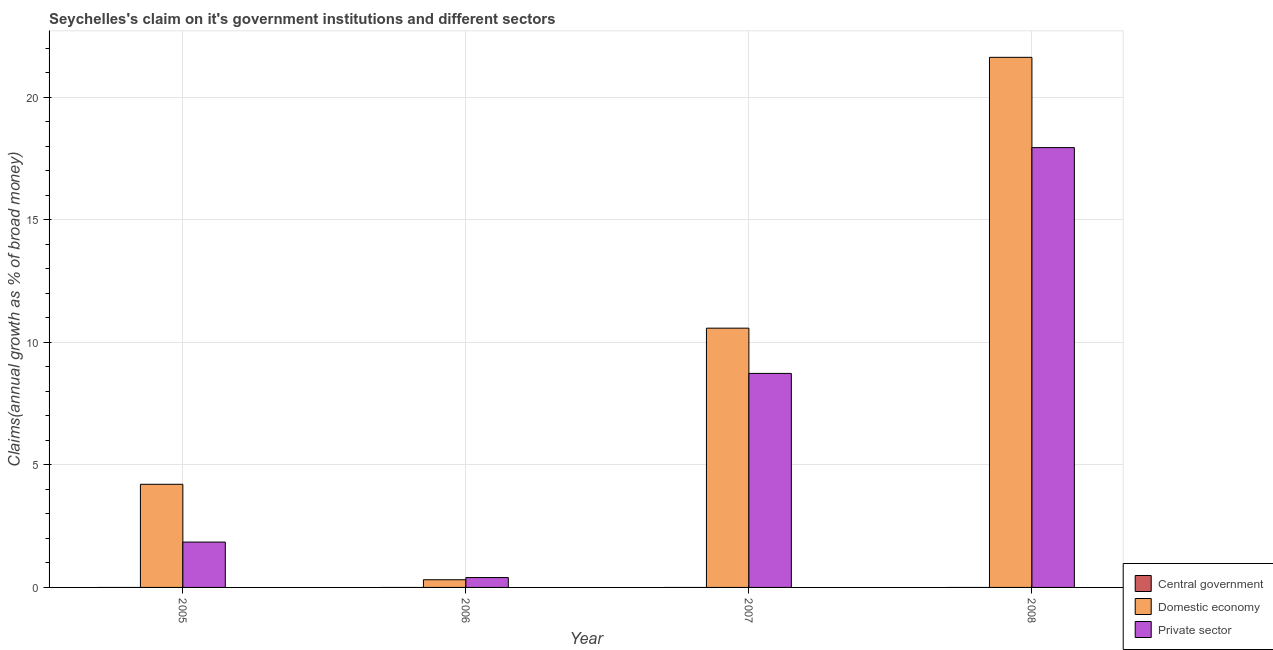How many different coloured bars are there?
Your answer should be very brief. 2. Are the number of bars per tick equal to the number of legend labels?
Keep it short and to the point. No. How many bars are there on the 1st tick from the left?
Make the answer very short. 2. What is the label of the 4th group of bars from the left?
Ensure brevity in your answer.  2008. In how many cases, is the number of bars for a given year not equal to the number of legend labels?
Offer a terse response. 4. What is the percentage of claim on the private sector in 2005?
Offer a very short reply. 1.85. Across all years, what is the maximum percentage of claim on the domestic economy?
Your answer should be compact. 21.63. Across all years, what is the minimum percentage of claim on the domestic economy?
Offer a very short reply. 0.31. What is the total percentage of claim on the central government in the graph?
Keep it short and to the point. 0. What is the difference between the percentage of claim on the domestic economy in 2007 and that in 2008?
Your answer should be compact. -11.05. What is the difference between the percentage of claim on the domestic economy in 2007 and the percentage of claim on the central government in 2005?
Provide a short and direct response. 6.37. What is the average percentage of claim on the private sector per year?
Provide a short and direct response. 7.23. In the year 2008, what is the difference between the percentage of claim on the private sector and percentage of claim on the domestic economy?
Your response must be concise. 0. What is the ratio of the percentage of claim on the private sector in 2005 to that in 2006?
Give a very brief answer. 4.6. Is the difference between the percentage of claim on the private sector in 2005 and 2007 greater than the difference between the percentage of claim on the central government in 2005 and 2007?
Your answer should be compact. No. What is the difference between the highest and the second highest percentage of claim on the domestic economy?
Your answer should be very brief. 11.05. What is the difference between the highest and the lowest percentage of claim on the private sector?
Make the answer very short. 17.55. Is it the case that in every year, the sum of the percentage of claim on the central government and percentage of claim on the domestic economy is greater than the percentage of claim on the private sector?
Offer a very short reply. No. How many bars are there?
Give a very brief answer. 8. Are all the bars in the graph horizontal?
Ensure brevity in your answer.  No. What is the difference between two consecutive major ticks on the Y-axis?
Your response must be concise. 5. Does the graph contain grids?
Offer a very short reply. Yes. Where does the legend appear in the graph?
Make the answer very short. Bottom right. How are the legend labels stacked?
Your answer should be very brief. Vertical. What is the title of the graph?
Ensure brevity in your answer.  Seychelles's claim on it's government institutions and different sectors. What is the label or title of the X-axis?
Your response must be concise. Year. What is the label or title of the Y-axis?
Give a very brief answer. Claims(annual growth as % of broad money). What is the Claims(annual growth as % of broad money) in Domestic economy in 2005?
Keep it short and to the point. 4.21. What is the Claims(annual growth as % of broad money) in Private sector in 2005?
Keep it short and to the point. 1.85. What is the Claims(annual growth as % of broad money) of Domestic economy in 2006?
Provide a succinct answer. 0.31. What is the Claims(annual growth as % of broad money) of Private sector in 2006?
Make the answer very short. 0.4. What is the Claims(annual growth as % of broad money) of Central government in 2007?
Make the answer very short. 0. What is the Claims(annual growth as % of broad money) of Domestic economy in 2007?
Ensure brevity in your answer.  10.58. What is the Claims(annual growth as % of broad money) of Private sector in 2007?
Offer a very short reply. 8.73. What is the Claims(annual growth as % of broad money) of Domestic economy in 2008?
Offer a very short reply. 21.63. What is the Claims(annual growth as % of broad money) of Private sector in 2008?
Make the answer very short. 17.95. Across all years, what is the maximum Claims(annual growth as % of broad money) of Domestic economy?
Give a very brief answer. 21.63. Across all years, what is the maximum Claims(annual growth as % of broad money) in Private sector?
Offer a terse response. 17.95. Across all years, what is the minimum Claims(annual growth as % of broad money) of Domestic economy?
Provide a short and direct response. 0.31. Across all years, what is the minimum Claims(annual growth as % of broad money) of Private sector?
Give a very brief answer. 0.4. What is the total Claims(annual growth as % of broad money) of Central government in the graph?
Your answer should be compact. 0. What is the total Claims(annual growth as % of broad money) of Domestic economy in the graph?
Your answer should be very brief. 36.74. What is the total Claims(annual growth as % of broad money) of Private sector in the graph?
Your answer should be very brief. 28.94. What is the difference between the Claims(annual growth as % of broad money) of Domestic economy in 2005 and that in 2006?
Give a very brief answer. 3.9. What is the difference between the Claims(annual growth as % of broad money) in Private sector in 2005 and that in 2006?
Make the answer very short. 1.45. What is the difference between the Claims(annual growth as % of broad money) in Domestic economy in 2005 and that in 2007?
Ensure brevity in your answer.  -6.37. What is the difference between the Claims(annual growth as % of broad money) in Private sector in 2005 and that in 2007?
Keep it short and to the point. -6.88. What is the difference between the Claims(annual growth as % of broad money) in Domestic economy in 2005 and that in 2008?
Offer a terse response. -17.42. What is the difference between the Claims(annual growth as % of broad money) in Private sector in 2005 and that in 2008?
Make the answer very short. -16.1. What is the difference between the Claims(annual growth as % of broad money) of Domestic economy in 2006 and that in 2007?
Ensure brevity in your answer.  -10.27. What is the difference between the Claims(annual growth as % of broad money) of Private sector in 2006 and that in 2007?
Give a very brief answer. -8.33. What is the difference between the Claims(annual growth as % of broad money) in Domestic economy in 2006 and that in 2008?
Your response must be concise. -21.32. What is the difference between the Claims(annual growth as % of broad money) in Private sector in 2006 and that in 2008?
Provide a succinct answer. -17.55. What is the difference between the Claims(annual growth as % of broad money) in Domestic economy in 2007 and that in 2008?
Offer a very short reply. -11.05. What is the difference between the Claims(annual growth as % of broad money) of Private sector in 2007 and that in 2008?
Make the answer very short. -9.22. What is the difference between the Claims(annual growth as % of broad money) of Domestic economy in 2005 and the Claims(annual growth as % of broad money) of Private sector in 2006?
Ensure brevity in your answer.  3.81. What is the difference between the Claims(annual growth as % of broad money) in Domestic economy in 2005 and the Claims(annual growth as % of broad money) in Private sector in 2007?
Your answer should be compact. -4.52. What is the difference between the Claims(annual growth as % of broad money) in Domestic economy in 2005 and the Claims(annual growth as % of broad money) in Private sector in 2008?
Make the answer very short. -13.74. What is the difference between the Claims(annual growth as % of broad money) of Domestic economy in 2006 and the Claims(annual growth as % of broad money) of Private sector in 2007?
Offer a very short reply. -8.42. What is the difference between the Claims(annual growth as % of broad money) in Domestic economy in 2006 and the Claims(annual growth as % of broad money) in Private sector in 2008?
Give a very brief answer. -17.64. What is the difference between the Claims(annual growth as % of broad money) of Domestic economy in 2007 and the Claims(annual growth as % of broad money) of Private sector in 2008?
Make the answer very short. -7.37. What is the average Claims(annual growth as % of broad money) of Central government per year?
Offer a very short reply. 0. What is the average Claims(annual growth as % of broad money) in Domestic economy per year?
Offer a terse response. 9.18. What is the average Claims(annual growth as % of broad money) of Private sector per year?
Your answer should be very brief. 7.23. In the year 2005, what is the difference between the Claims(annual growth as % of broad money) in Domestic economy and Claims(annual growth as % of broad money) in Private sector?
Ensure brevity in your answer.  2.36. In the year 2006, what is the difference between the Claims(annual growth as % of broad money) in Domestic economy and Claims(annual growth as % of broad money) in Private sector?
Your response must be concise. -0.09. In the year 2007, what is the difference between the Claims(annual growth as % of broad money) of Domestic economy and Claims(annual growth as % of broad money) of Private sector?
Provide a short and direct response. 1.85. In the year 2008, what is the difference between the Claims(annual growth as % of broad money) in Domestic economy and Claims(annual growth as % of broad money) in Private sector?
Ensure brevity in your answer.  3.68. What is the ratio of the Claims(annual growth as % of broad money) of Domestic economy in 2005 to that in 2006?
Provide a short and direct response. 13.43. What is the ratio of the Claims(annual growth as % of broad money) of Private sector in 2005 to that in 2006?
Your answer should be compact. 4.6. What is the ratio of the Claims(annual growth as % of broad money) of Domestic economy in 2005 to that in 2007?
Provide a short and direct response. 0.4. What is the ratio of the Claims(annual growth as % of broad money) of Private sector in 2005 to that in 2007?
Offer a very short reply. 0.21. What is the ratio of the Claims(annual growth as % of broad money) of Domestic economy in 2005 to that in 2008?
Give a very brief answer. 0.19. What is the ratio of the Claims(annual growth as % of broad money) of Private sector in 2005 to that in 2008?
Keep it short and to the point. 0.1. What is the ratio of the Claims(annual growth as % of broad money) of Domestic economy in 2006 to that in 2007?
Your response must be concise. 0.03. What is the ratio of the Claims(annual growth as % of broad money) of Private sector in 2006 to that in 2007?
Your answer should be compact. 0.05. What is the ratio of the Claims(annual growth as % of broad money) in Domestic economy in 2006 to that in 2008?
Offer a very short reply. 0.01. What is the ratio of the Claims(annual growth as % of broad money) of Private sector in 2006 to that in 2008?
Give a very brief answer. 0.02. What is the ratio of the Claims(annual growth as % of broad money) in Domestic economy in 2007 to that in 2008?
Offer a terse response. 0.49. What is the ratio of the Claims(annual growth as % of broad money) in Private sector in 2007 to that in 2008?
Offer a terse response. 0.49. What is the difference between the highest and the second highest Claims(annual growth as % of broad money) of Domestic economy?
Give a very brief answer. 11.05. What is the difference between the highest and the second highest Claims(annual growth as % of broad money) in Private sector?
Provide a succinct answer. 9.22. What is the difference between the highest and the lowest Claims(annual growth as % of broad money) in Domestic economy?
Your answer should be compact. 21.32. What is the difference between the highest and the lowest Claims(annual growth as % of broad money) of Private sector?
Your response must be concise. 17.55. 